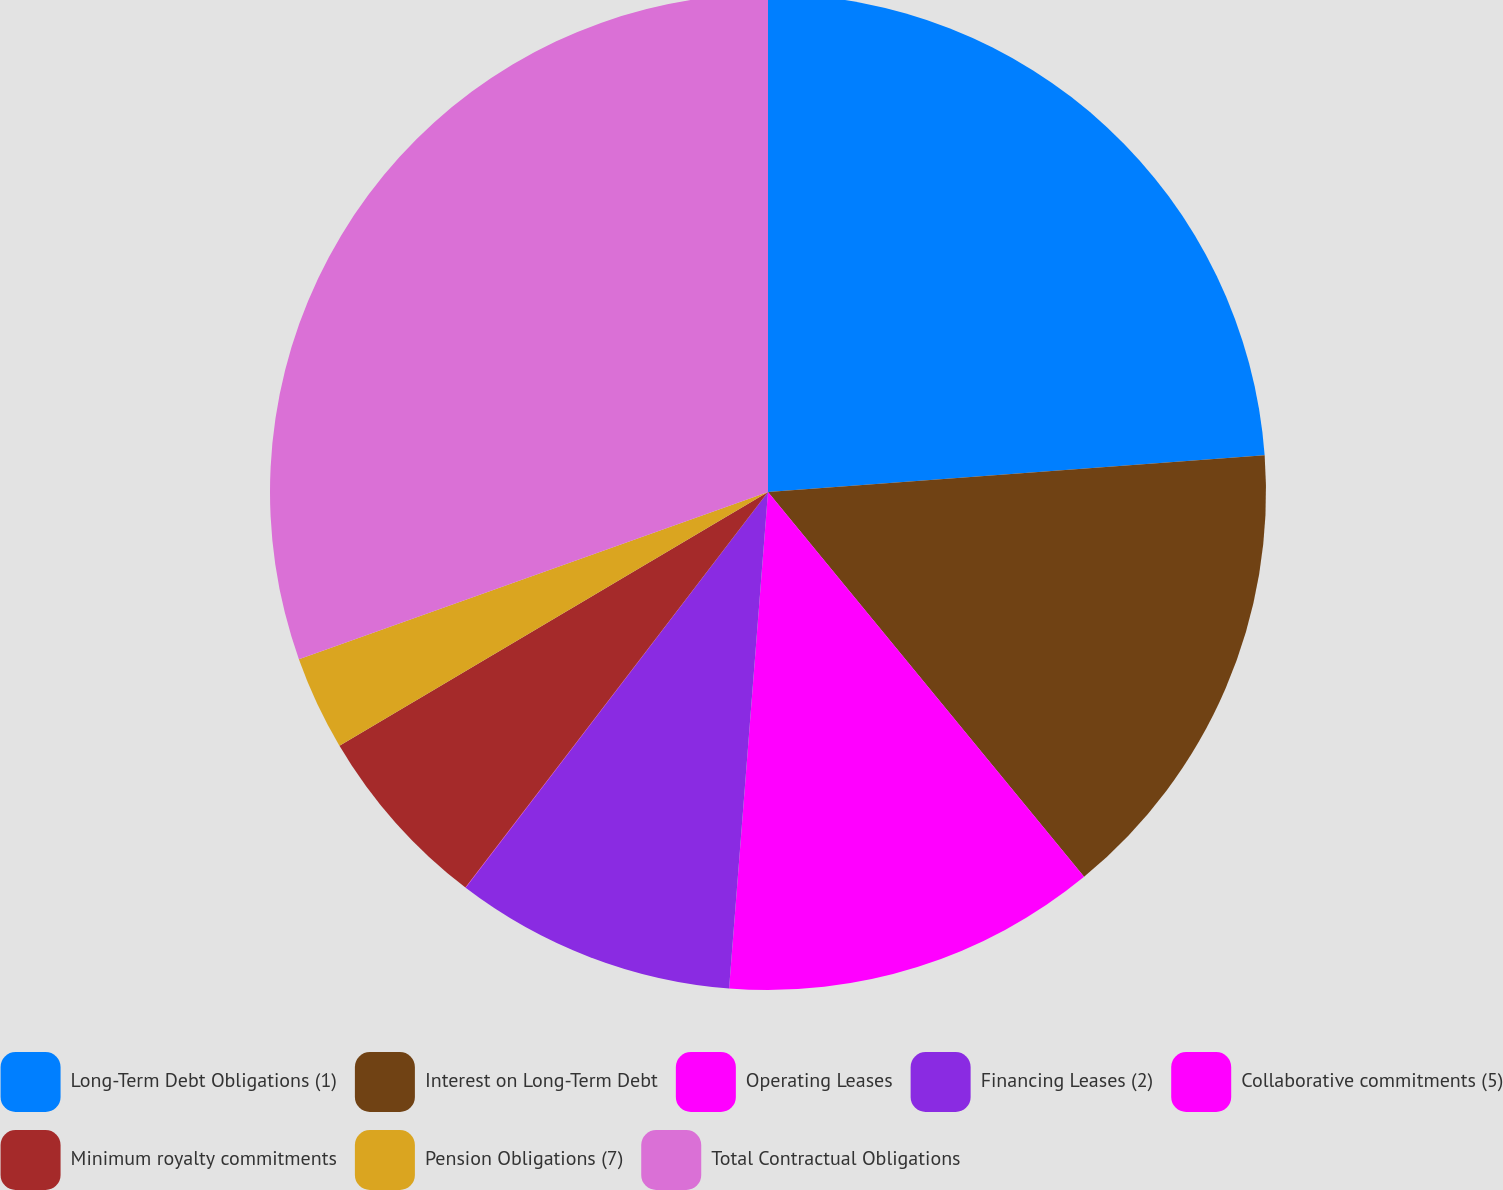Convert chart to OTSL. <chart><loc_0><loc_0><loc_500><loc_500><pie_chart><fcel>Long-Term Debt Obligations (1)<fcel>Interest on Long-Term Debt<fcel>Operating Leases<fcel>Financing Leases (2)<fcel>Collaborative commitments (5)<fcel>Minimum royalty commitments<fcel>Pension Obligations (7)<fcel>Total Contractual Obligations<nl><fcel>23.83%<fcel>15.23%<fcel>12.19%<fcel>9.14%<fcel>0.01%<fcel>6.1%<fcel>3.06%<fcel>30.45%<nl></chart> 